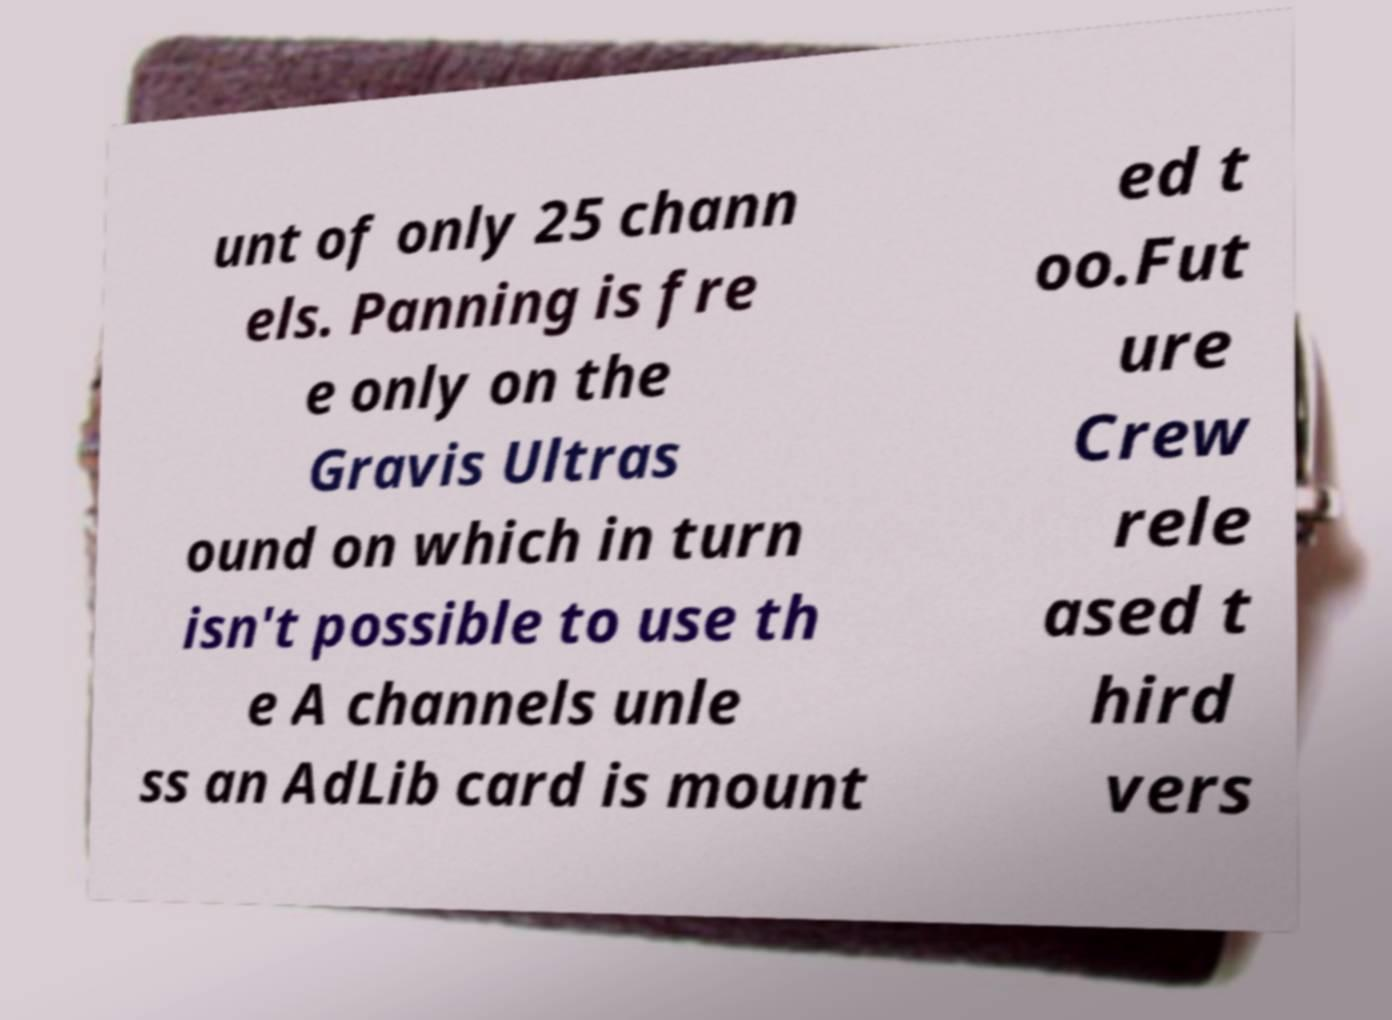Could you assist in decoding the text presented in this image and type it out clearly? unt of only 25 chann els. Panning is fre e only on the Gravis Ultras ound on which in turn isn't possible to use th e A channels unle ss an AdLib card is mount ed t oo.Fut ure Crew rele ased t hird vers 